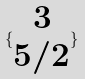<formula> <loc_0><loc_0><loc_500><loc_500>\{ \begin{matrix} 3 \\ 5 / 2 \end{matrix} \}</formula> 